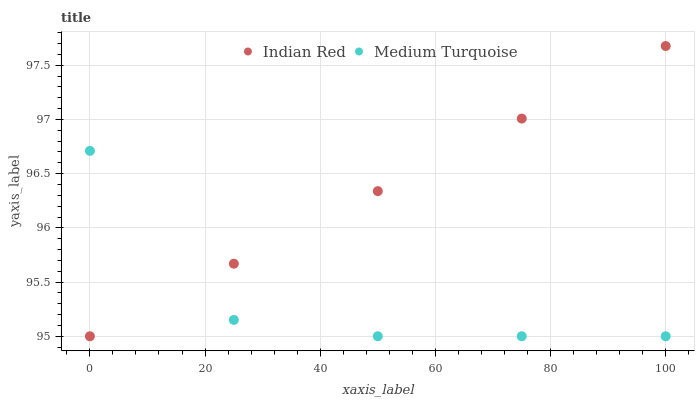Does Medium Turquoise have the minimum area under the curve?
Answer yes or no. Yes. Does Indian Red have the maximum area under the curve?
Answer yes or no. Yes. Does Indian Red have the minimum area under the curve?
Answer yes or no. No. Is Indian Red the smoothest?
Answer yes or no. Yes. Is Medium Turquoise the roughest?
Answer yes or no. Yes. Is Indian Red the roughest?
Answer yes or no. No. Does Medium Turquoise have the lowest value?
Answer yes or no. Yes. Does Indian Red have the highest value?
Answer yes or no. Yes. Does Medium Turquoise intersect Indian Red?
Answer yes or no. Yes. Is Medium Turquoise less than Indian Red?
Answer yes or no. No. Is Medium Turquoise greater than Indian Red?
Answer yes or no. No. 